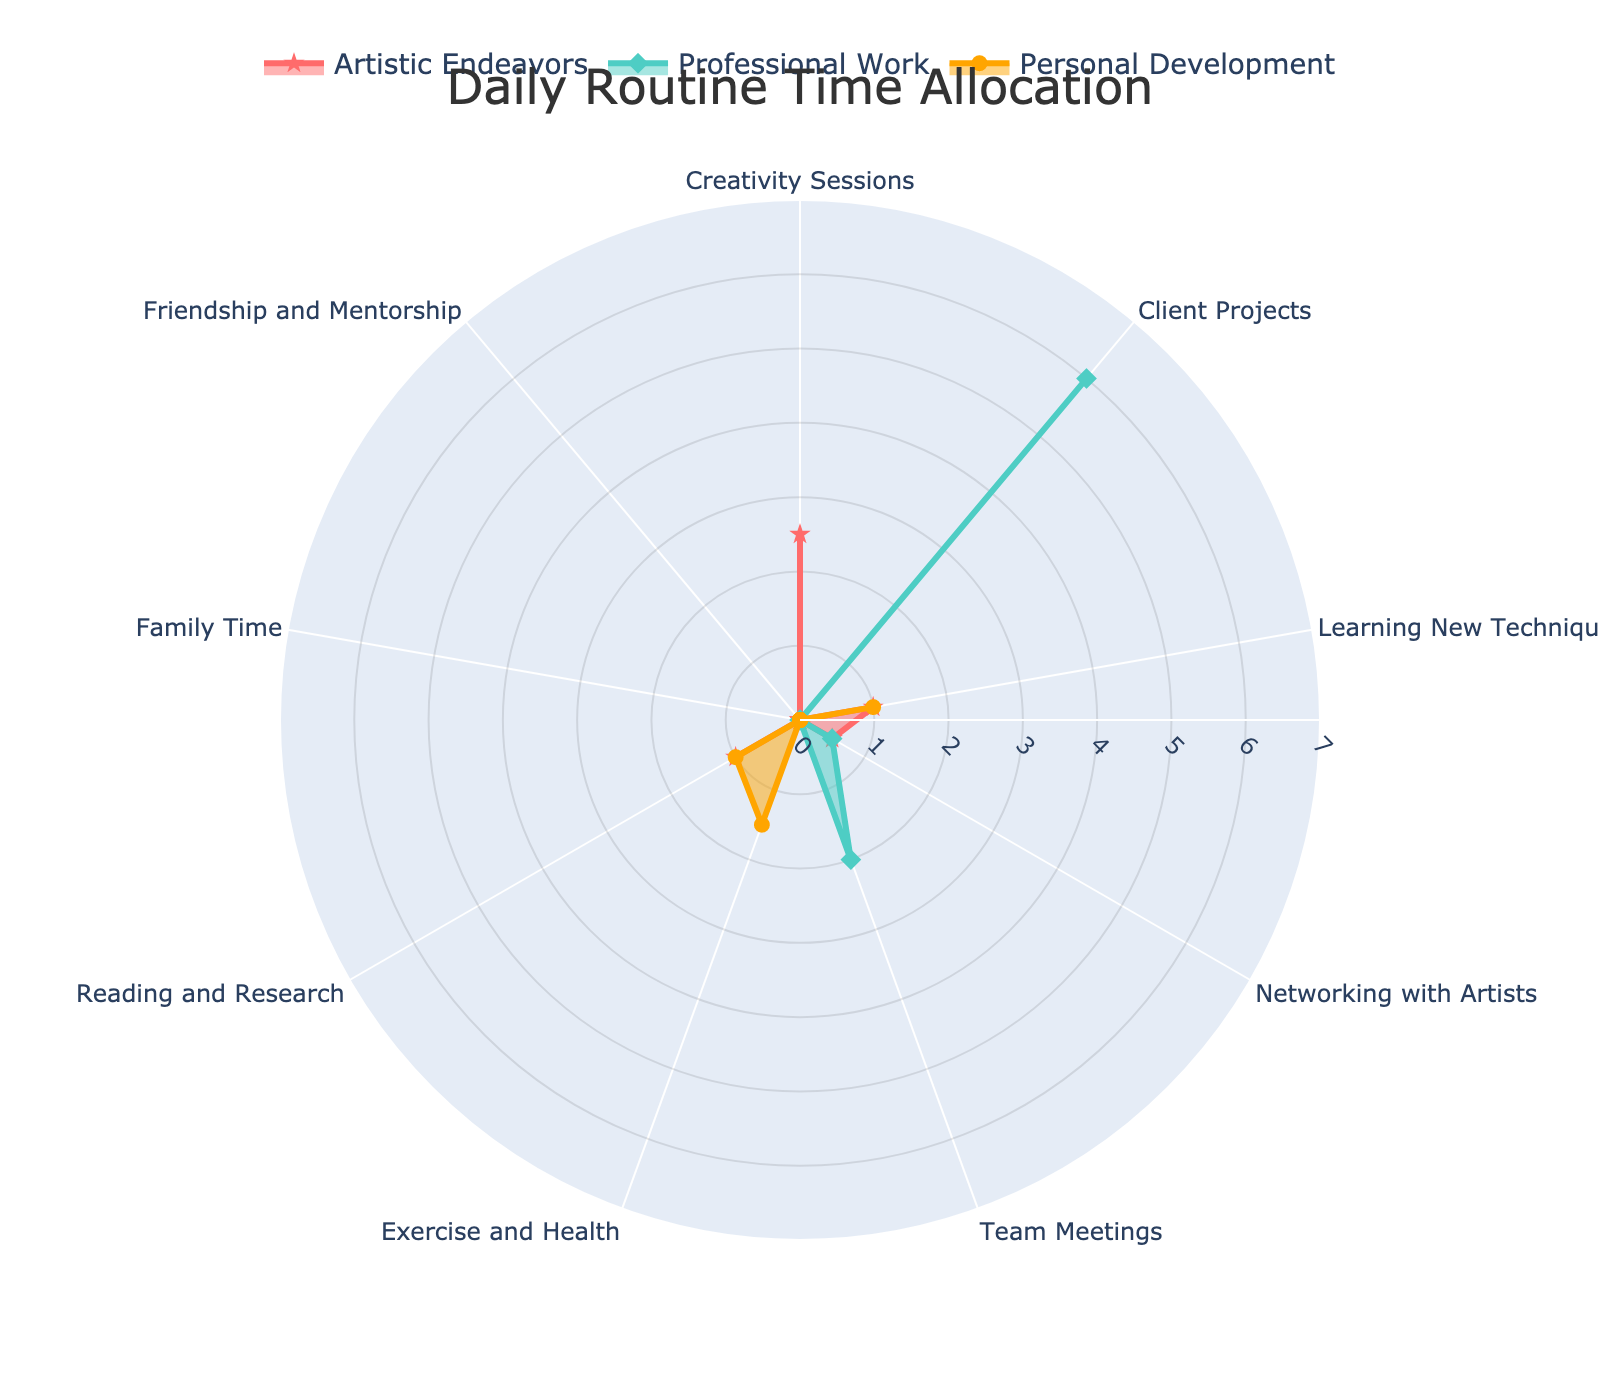What is the title of the figure? The title is usually displayed at the top of the radar chart, and here it reads "Daily Routine Time Allocation."
Answer: Daily Routine Time Allocation Which category has the highest value for Artistic Endeavors? Looking at the "Creativity Sessions" category, the value for Artistic Endeavors is the highest at 2.5 hours.
Answer: Creativity Sessions How much time is allocated to Learning New Techniques across all groups? Sum the values of Learning New Techniques for all groups: Artistic Endeavors (1) + Professional Work (0) + Personal Development (1) = 2 hours.
Answer: 2 hours Compare the time spent on Team Meetings and Family Time for Professional Work. Which one is higher? The value of Team Meetings for Professional Work is 2 hours, while Family Time is not allocated any time (0 hours), so Team Meetings has a higher value.
Answer: Team Meetings What is the average amount of time spent in Networking with Artists across all groups? Sum the values for Networking with Artists across the groups and divide by the number of groups: (0.5 + 0.5 + 1)/3 = 2/3 ≈ 0.67 hours.
Answer: 0.67 hours Which group has a higher total time allocation, Artistic Endeavors or Personal Development? Sum the values across categories for each group: Artistic Endeavors (2.5+0+1+0.5+0+0+1+0+0) = 5 hours, Personal Development (0+0+1+0+0+1.5+1+0+0) = 3.5 hours. Artistic Endeavors has a higher total time allocation.
Answer: Artistic Endeavors How much more time is allocated to Professional Work than to Personal Development in Client Projects? Professional Work in Client Projects is allocated 6 hours, while Personal Development has 0 hours, so the difference is 6 hours.
Answer: 6 hours Which category has the smallest variation across all groups? By observing the radar chart’s consistency across groups, "Client Projects" has values of 0 (Artistic Endeavors and Personal Development) and 6 (Professional Work), showcasing high variation. Meanwhile, "Exercise and Health" is only allocated within Personal Development (1.5 hours), indicating minimal variation.
Answer: Exercise and Health 